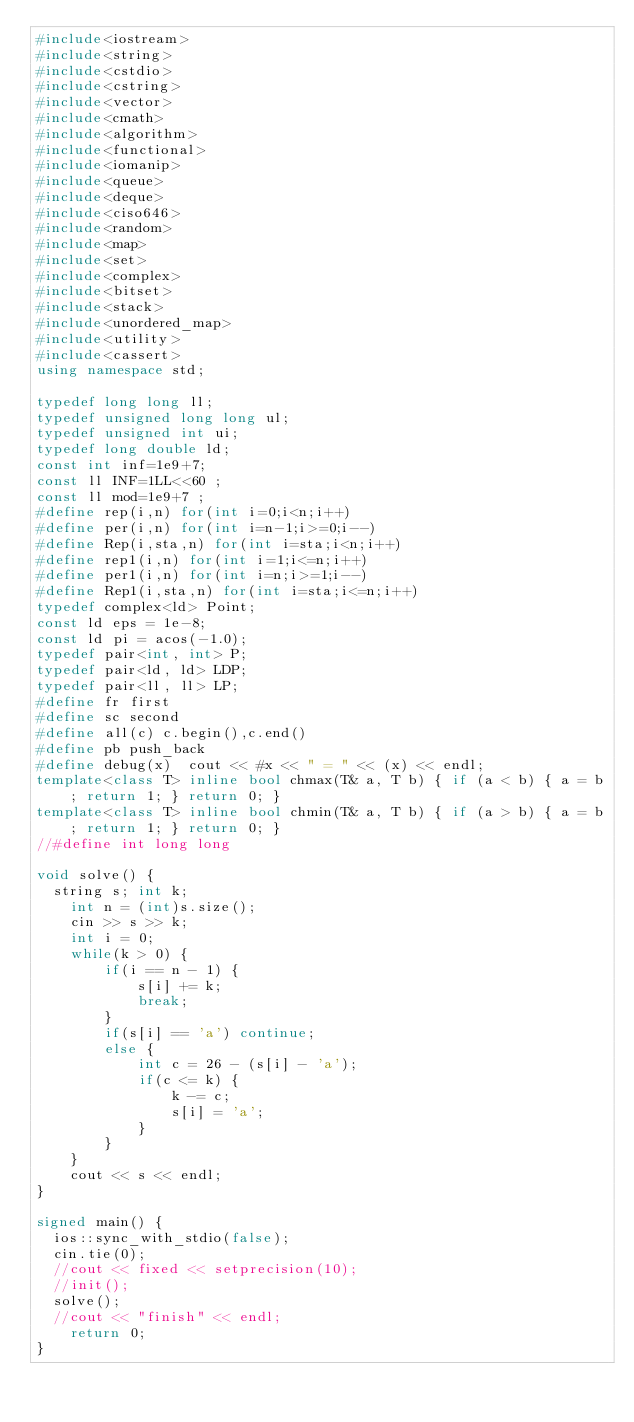Convert code to text. <code><loc_0><loc_0><loc_500><loc_500><_C++_>#include<iostream>
#include<string>
#include<cstdio>
#include<cstring>
#include<vector>
#include<cmath>
#include<algorithm>
#include<functional>
#include<iomanip>
#include<queue>
#include<deque>
#include<ciso646>
#include<random>
#include<map>
#include<set>
#include<complex>
#include<bitset>
#include<stack>
#include<unordered_map>
#include<utility>
#include<cassert>
using namespace std;

typedef long long ll;
typedef unsigned long long ul;
typedef unsigned int ui;
typedef long double ld;
const int inf=1e9+7;
const ll INF=1LL<<60 ;
const ll mod=1e9+7 ;
#define rep(i,n) for(int i=0;i<n;i++)
#define per(i,n) for(int i=n-1;i>=0;i--)
#define Rep(i,sta,n) for(int i=sta;i<n;i++)
#define rep1(i,n) for(int i=1;i<=n;i++)
#define per1(i,n) for(int i=n;i>=1;i--)
#define Rep1(i,sta,n) for(int i=sta;i<=n;i++)
typedef complex<ld> Point;
const ld eps = 1e-8;
const ld pi = acos(-1.0);
typedef pair<int, int> P;
typedef pair<ld, ld> LDP;
typedef pair<ll, ll> LP;
#define fr first
#define sc second
#define all(c) c.begin(),c.end()
#define pb push_back
#define debug(x)  cout << #x << " = " << (x) << endl;
template<class T> inline bool chmax(T& a, T b) { if (a < b) { a = b; return 1; } return 0; }
template<class T> inline bool chmin(T& a, T b) { if (a > b) { a = b; return 1; } return 0; }
//#define int long long

void solve() {
	string s; int k;
    int n = (int)s.size();
    cin >> s >> k;
    int i = 0;
    while(k > 0) {
        if(i == n - 1) {
            s[i] += k;
            break;
        }
        if(s[i] == 'a') continue;
        else {
            int c = 26 - (s[i] - 'a');
            if(c <= k) {
                k -= c;
                s[i] = 'a';
            }
        }
    }
    cout << s << endl;
}

signed main() {
	ios::sync_with_stdio(false);
	cin.tie(0);
	//cout << fixed << setprecision(10);
	//init();
	solve();
	//cout << "finish" << endl;
    return 0;
}</code> 